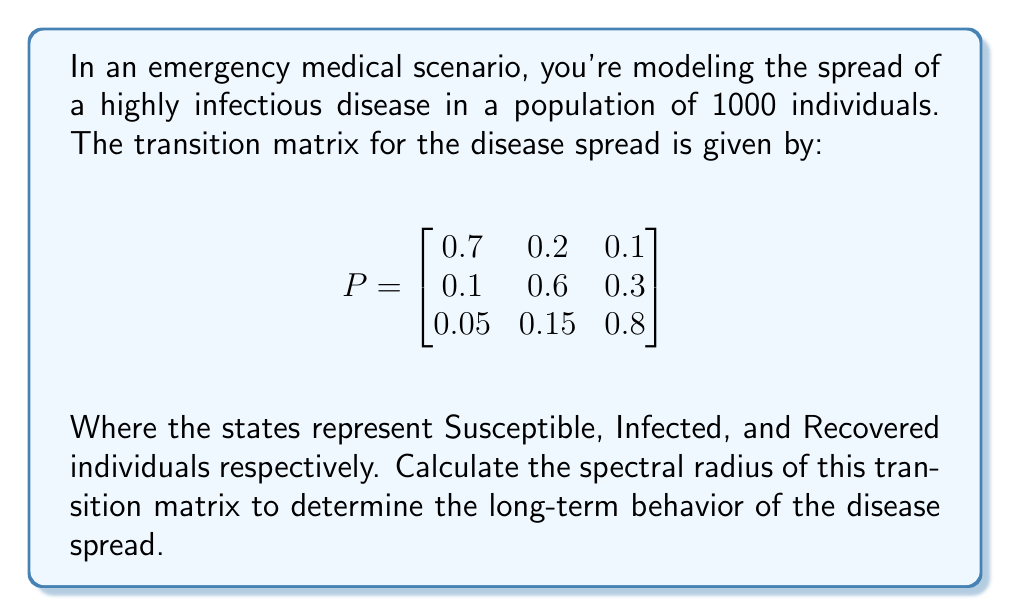Solve this math problem. To find the spectral radius of the transition matrix, we need to follow these steps:

1) First, we need to find the eigenvalues of the matrix P. The characteristic equation is:

   $$det(P - \lambda I) = 0$$

2) Expanding this, we get:

   $$(0.7 - \lambda)(0.6 - \lambda)(0.8 - \lambda) - 0.1 \cdot 0.3 \cdot 0.05 - 0.1 \cdot 0.2 \cdot 0.15 - 0.2 \cdot 0.1 \cdot 0.8 = 0$$

3) Simplifying:

   $$-\lambda^3 + 2.1\lambda^2 - 1.33\lambda + 0.2485 = 0$$

4) This cubic equation can be solved using numerical methods. The eigenvalues are approximately:

   $$\lambda_1 \approx 1.0000$$
   $$\lambda_2 \approx 0.5764$$
   $$\lambda_3 \approx 0.5236$$

5) The spectral radius is the maximum absolute value of the eigenvalues:

   $$\rho(P) = \max(|\lambda_1|, |\lambda_2|, |\lambda_3|) = 1.0000$$

6) Since the spectral radius is 1, this indicates that the disease will reach an endemic equilibrium in the long term, neither dying out nor growing exponentially.
Answer: $\rho(P) = 1.0000$ 